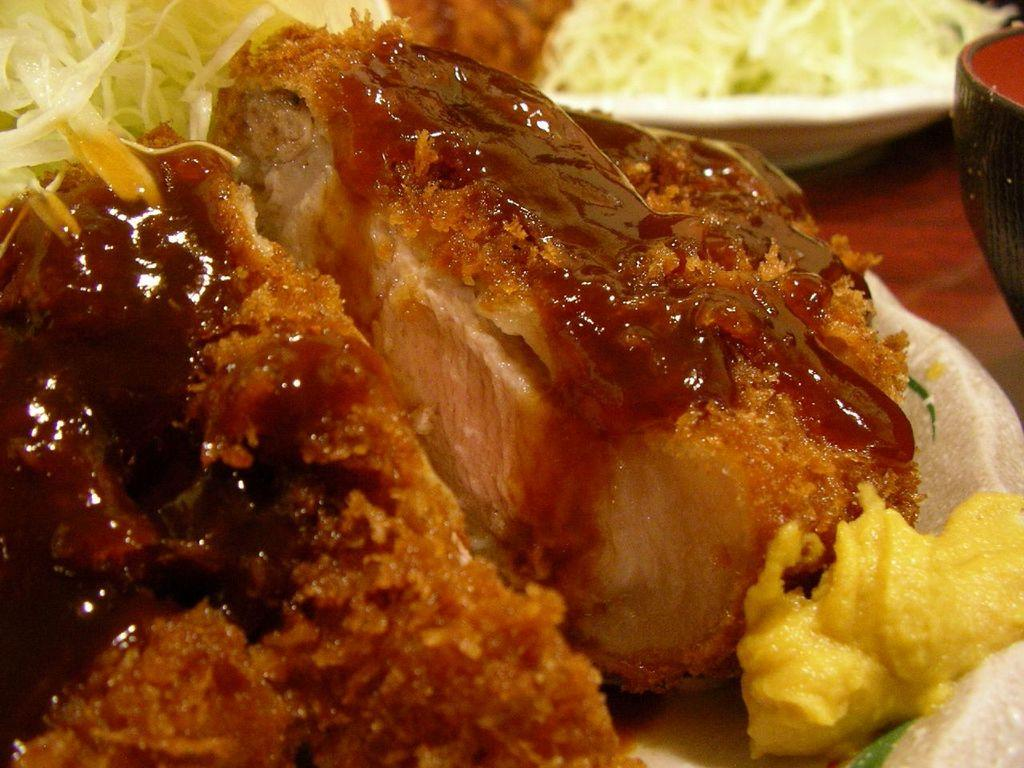What can be seen on the plates in the image? There are food items on plates in the image. What is the material of the surface on which the plates are placed? The plates are placed on a wooden surface. Where is the mother in the image? There is no mother present in the image; it only shows plates with food items on a wooden surface. 